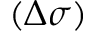Convert formula to latex. <formula><loc_0><loc_0><loc_500><loc_500>( \Delta \sigma )</formula> 